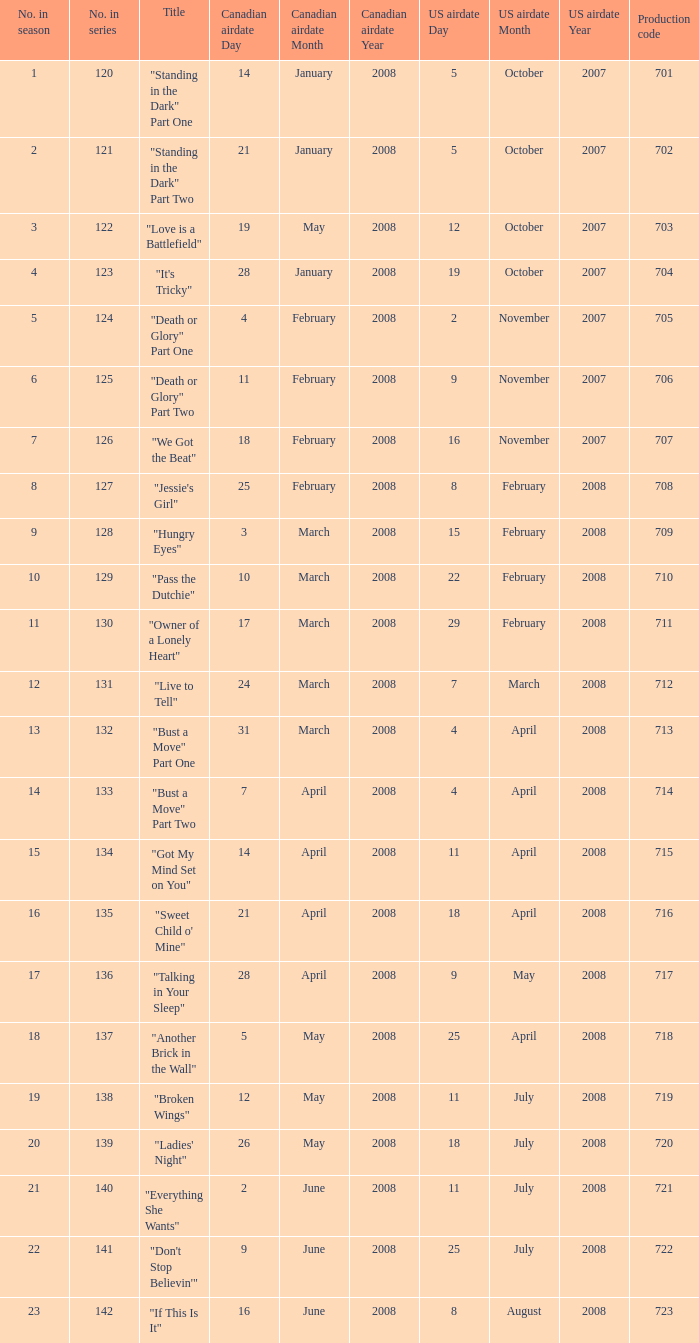The canadian airdate of 11 february 2008 applied to what series number? 1.0. 